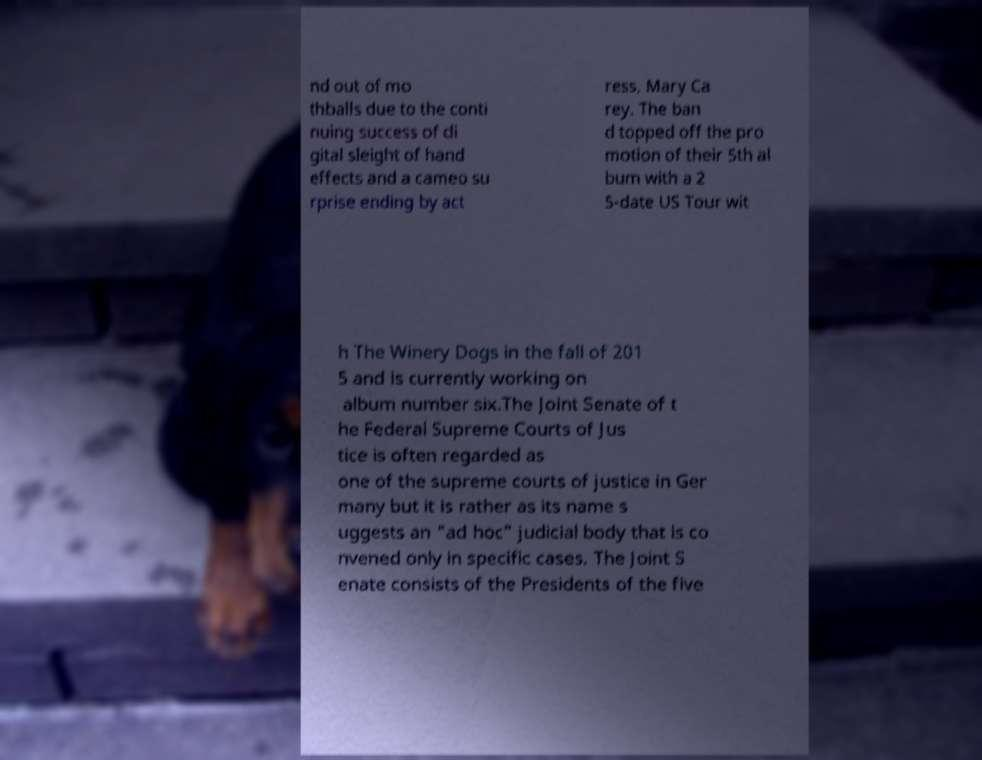Please read and relay the text visible in this image. What does it say? nd out of mo thballs due to the conti nuing success of di gital sleight of hand effects and a cameo su rprise ending by act ress, Mary Ca rey. The ban d topped off the pro motion of their 5th al bum with a 2 5-date US Tour wit h The Winery Dogs in the fall of 201 5 and is currently working on album number six.The Joint Senate of t he Federal Supreme Courts of Jus tice is often regarded as one of the supreme courts of justice in Ger many but it is rather as its name s uggests an "ad hoc" judicial body that is co nvened only in specific cases. The Joint S enate consists of the Presidents of the five 